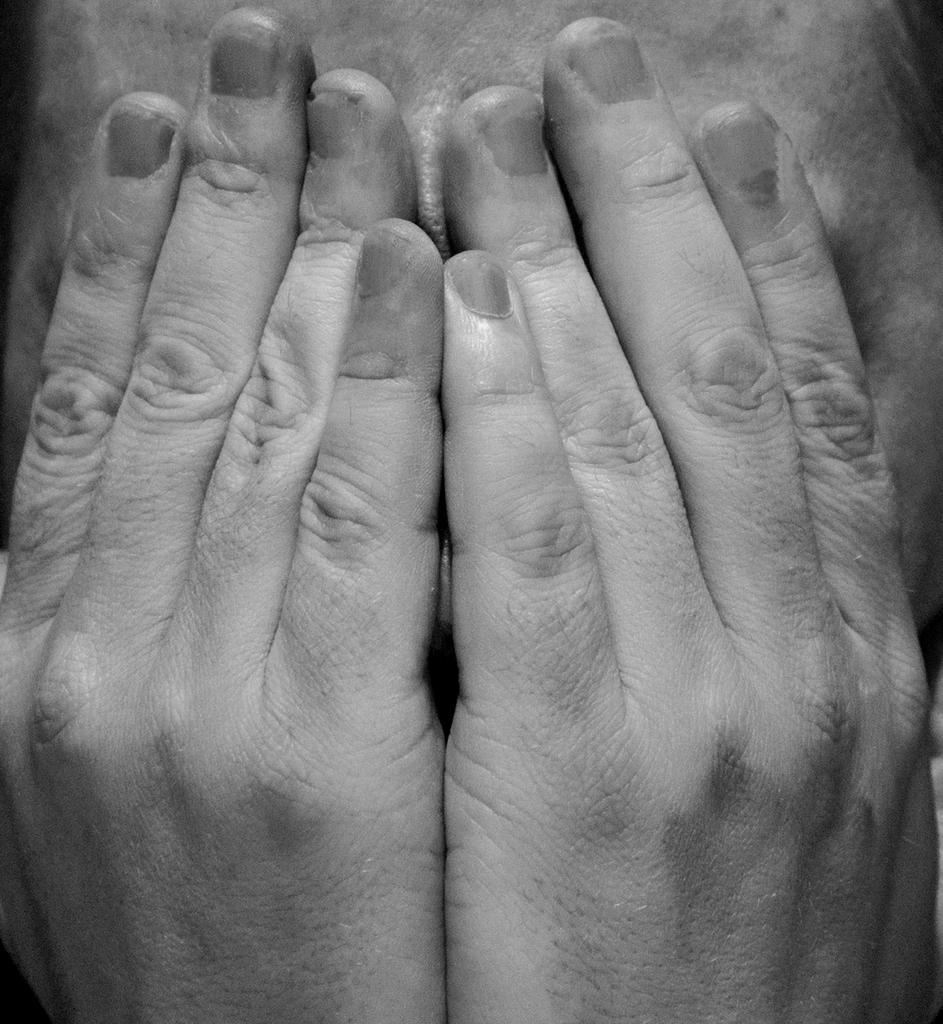What is the main subject of the image? There is a person in the image. What is the person doing in the image? The person is covering their face with their hands. What is the color scheme of the image? The image is black and white. What date is circled on the calendar in the image? There is no calendar present in the image. What type of fruit is being held by the person in the image? The person is covering their face with their hands, so it is not possible to determine if they are holding any fruit. 